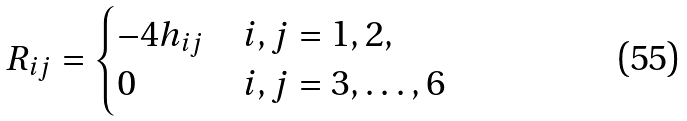<formula> <loc_0><loc_0><loc_500><loc_500>R _ { i j } = \begin{cases} - 4 h _ { i j } & i , j = 1 , 2 , \\ 0 & i , j = 3 , \dots , 6 \end{cases}</formula> 